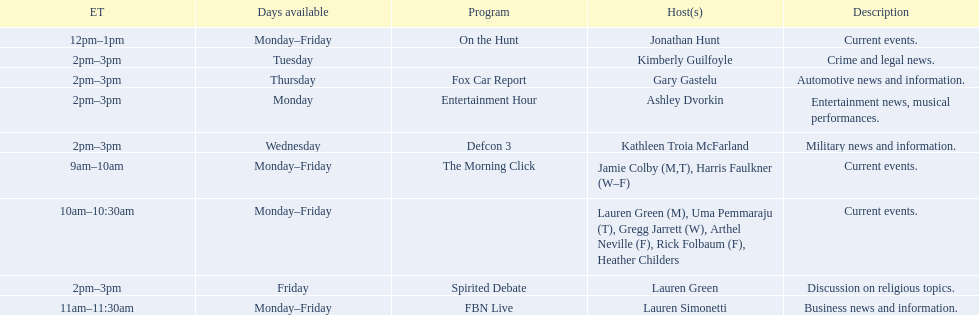Who are all of the hosts? Jamie Colby (M,T), Harris Faulkner (W–F), Lauren Green (M), Uma Pemmaraju (T), Gregg Jarrett (W), Arthel Neville (F), Rick Folbaum (F), Heather Childers, Lauren Simonetti, Jonathan Hunt, Ashley Dvorkin, Kimberly Guilfoyle, Kathleen Troia McFarland, Gary Gastelu, Lauren Green. Which hosts have shows on fridays? Jamie Colby (M,T), Harris Faulkner (W–F), Lauren Green (M), Uma Pemmaraju (T), Gregg Jarrett (W), Arthel Neville (F), Rick Folbaum (F), Heather Childers, Lauren Simonetti, Jonathan Hunt, Lauren Green. Of those, which host's show airs at 2pm? Lauren Green. 